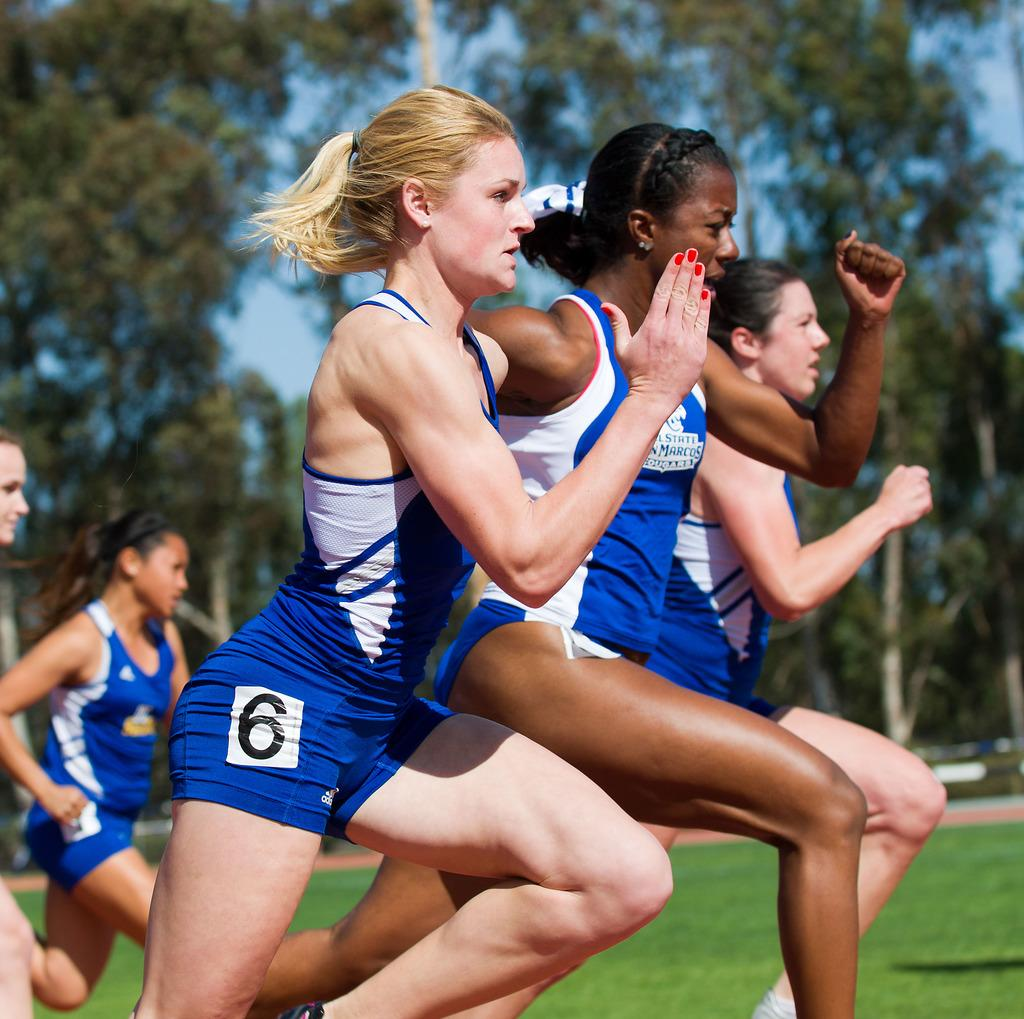<image>
Summarize the visual content of the image. Three runners are very close in a race with number 6 on the outside. 